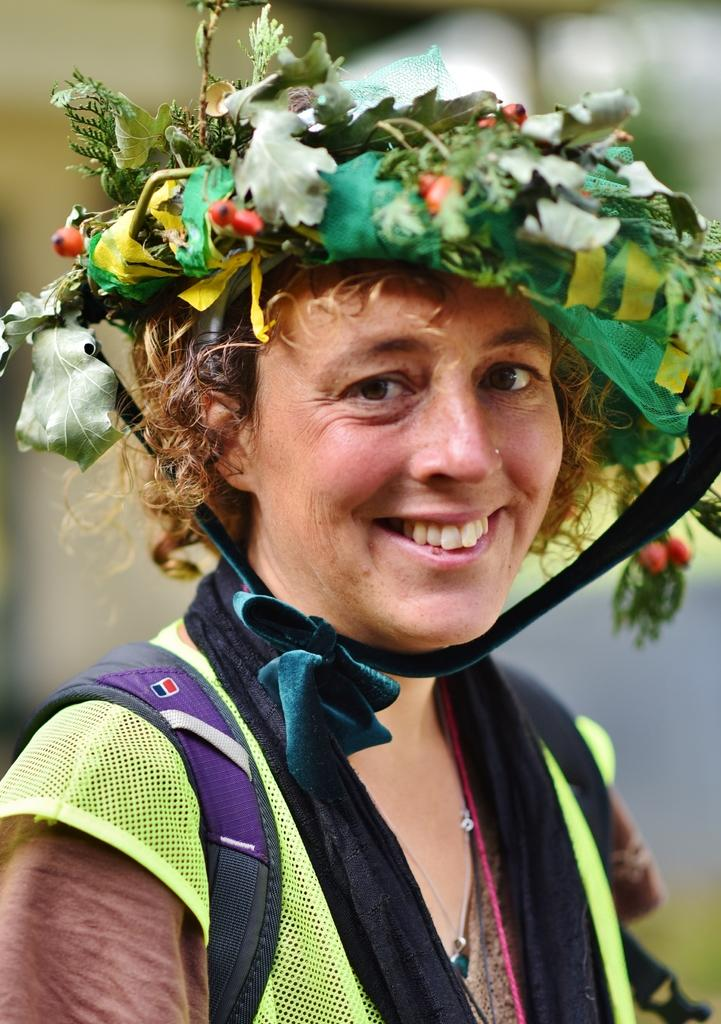Who is present in the image? There is a person in the image. What is the person wearing? The person is wearing a dress and a crown. Can you describe the crown? The crown has green, yellow, and red colors. What can be observed about the background of the image? The background of the image is blurred. What type of waste is visible in the image? There is no waste visible in the image. How many bites has the person taken out of the crown? The image does not show any bites taken out of the crown, as it is a static image. 